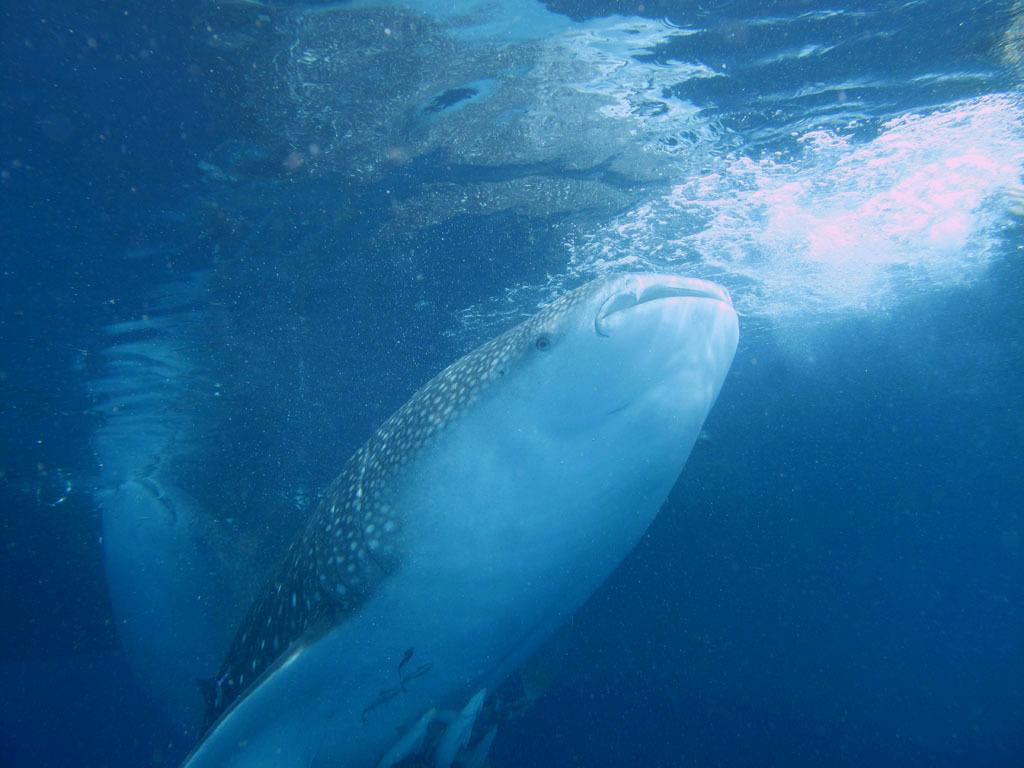What is the main subject of the image? There is a fish in the image. Where is the fish located? The fish is in water. Are there any other creatures visible in the water? Yes, there are small fishes in the water at the bottom of the image. What type of produce can be seen growing near the scarecrow in the image? There is no produce or scarecrow present in the image; it features a fish in water with small fishes at the bottom. 